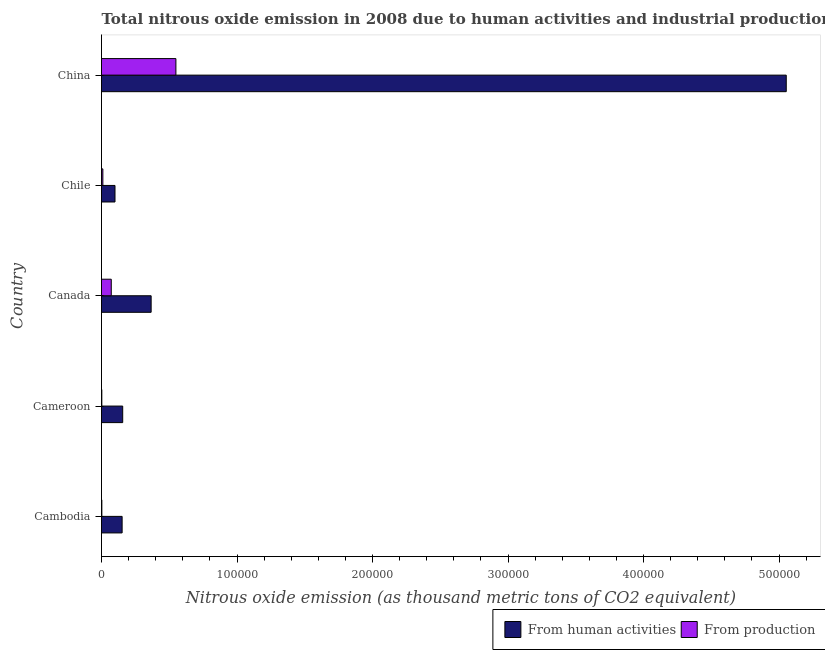How many groups of bars are there?
Make the answer very short. 5. Are the number of bars on each tick of the Y-axis equal?
Keep it short and to the point. Yes. How many bars are there on the 2nd tick from the top?
Make the answer very short. 2. How many bars are there on the 2nd tick from the bottom?
Offer a terse response. 2. What is the label of the 5th group of bars from the top?
Your answer should be very brief. Cambodia. What is the amount of emissions from human activities in China?
Offer a terse response. 5.05e+05. Across all countries, what is the maximum amount of emissions from human activities?
Keep it short and to the point. 5.05e+05. Across all countries, what is the minimum amount of emissions generated from industries?
Keep it short and to the point. 235.8. In which country was the amount of emissions from human activities maximum?
Offer a terse response. China. In which country was the amount of emissions generated from industries minimum?
Provide a short and direct response. Cameroon. What is the total amount of emissions from human activities in the graph?
Provide a short and direct response. 5.83e+05. What is the difference between the amount of emissions from human activities in Cambodia and that in Chile?
Your response must be concise. 5260.5. What is the difference between the amount of emissions from human activities in China and the amount of emissions generated from industries in Canada?
Provide a succinct answer. 4.98e+05. What is the average amount of emissions from human activities per country?
Your answer should be compact. 1.17e+05. What is the difference between the amount of emissions from human activities and amount of emissions generated from industries in Chile?
Make the answer very short. 8954.9. In how many countries, is the amount of emissions from human activities greater than 220000 thousand metric tons?
Provide a succinct answer. 1. What is the ratio of the amount of emissions generated from industries in Cameroon to that in Canada?
Your response must be concise. 0.03. Is the difference between the amount of emissions from human activities in Cambodia and Cameroon greater than the difference between the amount of emissions generated from industries in Cambodia and Cameroon?
Your answer should be compact. No. What is the difference between the highest and the second highest amount of emissions from human activities?
Offer a terse response. 4.69e+05. What is the difference between the highest and the lowest amount of emissions generated from industries?
Provide a short and direct response. 5.47e+04. In how many countries, is the amount of emissions from human activities greater than the average amount of emissions from human activities taken over all countries?
Provide a succinct answer. 1. What does the 1st bar from the top in Canada represents?
Your response must be concise. From production. What does the 1st bar from the bottom in Cameroon represents?
Provide a succinct answer. From human activities. How many countries are there in the graph?
Provide a succinct answer. 5. Does the graph contain grids?
Give a very brief answer. No. Where does the legend appear in the graph?
Provide a short and direct response. Bottom right. How many legend labels are there?
Offer a very short reply. 2. What is the title of the graph?
Your answer should be compact. Total nitrous oxide emission in 2008 due to human activities and industrial production. What is the label or title of the X-axis?
Provide a succinct answer. Nitrous oxide emission (as thousand metric tons of CO2 equivalent). What is the Nitrous oxide emission (as thousand metric tons of CO2 equivalent) in From human activities in Cambodia?
Offer a very short reply. 1.52e+04. What is the Nitrous oxide emission (as thousand metric tons of CO2 equivalent) of From production in Cambodia?
Your answer should be compact. 257.9. What is the Nitrous oxide emission (as thousand metric tons of CO2 equivalent) in From human activities in Cameroon?
Provide a short and direct response. 1.56e+04. What is the Nitrous oxide emission (as thousand metric tons of CO2 equivalent) of From production in Cameroon?
Ensure brevity in your answer.  235.8. What is the Nitrous oxide emission (as thousand metric tons of CO2 equivalent) of From human activities in Canada?
Your response must be concise. 3.66e+04. What is the Nitrous oxide emission (as thousand metric tons of CO2 equivalent) of From production in Canada?
Keep it short and to the point. 7205.4. What is the Nitrous oxide emission (as thousand metric tons of CO2 equivalent) in From human activities in Chile?
Your answer should be compact. 9956.7. What is the Nitrous oxide emission (as thousand metric tons of CO2 equivalent) in From production in Chile?
Make the answer very short. 1001.8. What is the Nitrous oxide emission (as thousand metric tons of CO2 equivalent) of From human activities in China?
Your answer should be very brief. 5.05e+05. What is the Nitrous oxide emission (as thousand metric tons of CO2 equivalent) of From production in China?
Offer a very short reply. 5.49e+04. Across all countries, what is the maximum Nitrous oxide emission (as thousand metric tons of CO2 equivalent) in From human activities?
Your response must be concise. 5.05e+05. Across all countries, what is the maximum Nitrous oxide emission (as thousand metric tons of CO2 equivalent) in From production?
Make the answer very short. 5.49e+04. Across all countries, what is the minimum Nitrous oxide emission (as thousand metric tons of CO2 equivalent) in From human activities?
Ensure brevity in your answer.  9956.7. Across all countries, what is the minimum Nitrous oxide emission (as thousand metric tons of CO2 equivalent) of From production?
Your answer should be very brief. 235.8. What is the total Nitrous oxide emission (as thousand metric tons of CO2 equivalent) in From human activities in the graph?
Make the answer very short. 5.83e+05. What is the total Nitrous oxide emission (as thousand metric tons of CO2 equivalent) in From production in the graph?
Provide a short and direct response. 6.36e+04. What is the difference between the Nitrous oxide emission (as thousand metric tons of CO2 equivalent) of From human activities in Cambodia and that in Cameroon?
Your answer should be compact. -429.5. What is the difference between the Nitrous oxide emission (as thousand metric tons of CO2 equivalent) in From production in Cambodia and that in Cameroon?
Offer a terse response. 22.1. What is the difference between the Nitrous oxide emission (as thousand metric tons of CO2 equivalent) of From human activities in Cambodia and that in Canada?
Make the answer very short. -2.14e+04. What is the difference between the Nitrous oxide emission (as thousand metric tons of CO2 equivalent) in From production in Cambodia and that in Canada?
Provide a short and direct response. -6947.5. What is the difference between the Nitrous oxide emission (as thousand metric tons of CO2 equivalent) of From human activities in Cambodia and that in Chile?
Provide a short and direct response. 5260.5. What is the difference between the Nitrous oxide emission (as thousand metric tons of CO2 equivalent) in From production in Cambodia and that in Chile?
Your answer should be very brief. -743.9. What is the difference between the Nitrous oxide emission (as thousand metric tons of CO2 equivalent) of From human activities in Cambodia and that in China?
Keep it short and to the point. -4.90e+05. What is the difference between the Nitrous oxide emission (as thousand metric tons of CO2 equivalent) in From production in Cambodia and that in China?
Your response must be concise. -5.46e+04. What is the difference between the Nitrous oxide emission (as thousand metric tons of CO2 equivalent) of From human activities in Cameroon and that in Canada?
Give a very brief answer. -2.10e+04. What is the difference between the Nitrous oxide emission (as thousand metric tons of CO2 equivalent) of From production in Cameroon and that in Canada?
Make the answer very short. -6969.6. What is the difference between the Nitrous oxide emission (as thousand metric tons of CO2 equivalent) of From human activities in Cameroon and that in Chile?
Provide a succinct answer. 5690. What is the difference between the Nitrous oxide emission (as thousand metric tons of CO2 equivalent) in From production in Cameroon and that in Chile?
Your answer should be very brief. -766. What is the difference between the Nitrous oxide emission (as thousand metric tons of CO2 equivalent) of From human activities in Cameroon and that in China?
Your response must be concise. -4.90e+05. What is the difference between the Nitrous oxide emission (as thousand metric tons of CO2 equivalent) in From production in Cameroon and that in China?
Give a very brief answer. -5.47e+04. What is the difference between the Nitrous oxide emission (as thousand metric tons of CO2 equivalent) of From human activities in Canada and that in Chile?
Your answer should be very brief. 2.67e+04. What is the difference between the Nitrous oxide emission (as thousand metric tons of CO2 equivalent) in From production in Canada and that in Chile?
Offer a very short reply. 6203.6. What is the difference between the Nitrous oxide emission (as thousand metric tons of CO2 equivalent) of From human activities in Canada and that in China?
Your answer should be compact. -4.69e+05. What is the difference between the Nitrous oxide emission (as thousand metric tons of CO2 equivalent) in From production in Canada and that in China?
Your response must be concise. -4.77e+04. What is the difference between the Nitrous oxide emission (as thousand metric tons of CO2 equivalent) of From human activities in Chile and that in China?
Offer a terse response. -4.95e+05. What is the difference between the Nitrous oxide emission (as thousand metric tons of CO2 equivalent) of From production in Chile and that in China?
Your answer should be compact. -5.39e+04. What is the difference between the Nitrous oxide emission (as thousand metric tons of CO2 equivalent) in From human activities in Cambodia and the Nitrous oxide emission (as thousand metric tons of CO2 equivalent) in From production in Cameroon?
Provide a succinct answer. 1.50e+04. What is the difference between the Nitrous oxide emission (as thousand metric tons of CO2 equivalent) of From human activities in Cambodia and the Nitrous oxide emission (as thousand metric tons of CO2 equivalent) of From production in Canada?
Keep it short and to the point. 8011.8. What is the difference between the Nitrous oxide emission (as thousand metric tons of CO2 equivalent) of From human activities in Cambodia and the Nitrous oxide emission (as thousand metric tons of CO2 equivalent) of From production in Chile?
Provide a short and direct response. 1.42e+04. What is the difference between the Nitrous oxide emission (as thousand metric tons of CO2 equivalent) of From human activities in Cambodia and the Nitrous oxide emission (as thousand metric tons of CO2 equivalent) of From production in China?
Offer a terse response. -3.97e+04. What is the difference between the Nitrous oxide emission (as thousand metric tons of CO2 equivalent) in From human activities in Cameroon and the Nitrous oxide emission (as thousand metric tons of CO2 equivalent) in From production in Canada?
Provide a succinct answer. 8441.3. What is the difference between the Nitrous oxide emission (as thousand metric tons of CO2 equivalent) in From human activities in Cameroon and the Nitrous oxide emission (as thousand metric tons of CO2 equivalent) in From production in Chile?
Offer a terse response. 1.46e+04. What is the difference between the Nitrous oxide emission (as thousand metric tons of CO2 equivalent) of From human activities in Cameroon and the Nitrous oxide emission (as thousand metric tons of CO2 equivalent) of From production in China?
Make the answer very short. -3.93e+04. What is the difference between the Nitrous oxide emission (as thousand metric tons of CO2 equivalent) of From human activities in Canada and the Nitrous oxide emission (as thousand metric tons of CO2 equivalent) of From production in Chile?
Ensure brevity in your answer.  3.56e+04. What is the difference between the Nitrous oxide emission (as thousand metric tons of CO2 equivalent) in From human activities in Canada and the Nitrous oxide emission (as thousand metric tons of CO2 equivalent) in From production in China?
Offer a very short reply. -1.83e+04. What is the difference between the Nitrous oxide emission (as thousand metric tons of CO2 equivalent) of From human activities in Chile and the Nitrous oxide emission (as thousand metric tons of CO2 equivalent) of From production in China?
Offer a very short reply. -4.49e+04. What is the average Nitrous oxide emission (as thousand metric tons of CO2 equivalent) of From human activities per country?
Keep it short and to the point. 1.17e+05. What is the average Nitrous oxide emission (as thousand metric tons of CO2 equivalent) of From production per country?
Offer a terse response. 1.27e+04. What is the difference between the Nitrous oxide emission (as thousand metric tons of CO2 equivalent) of From human activities and Nitrous oxide emission (as thousand metric tons of CO2 equivalent) of From production in Cambodia?
Offer a terse response. 1.50e+04. What is the difference between the Nitrous oxide emission (as thousand metric tons of CO2 equivalent) in From human activities and Nitrous oxide emission (as thousand metric tons of CO2 equivalent) in From production in Cameroon?
Offer a very short reply. 1.54e+04. What is the difference between the Nitrous oxide emission (as thousand metric tons of CO2 equivalent) in From human activities and Nitrous oxide emission (as thousand metric tons of CO2 equivalent) in From production in Canada?
Offer a terse response. 2.94e+04. What is the difference between the Nitrous oxide emission (as thousand metric tons of CO2 equivalent) in From human activities and Nitrous oxide emission (as thousand metric tons of CO2 equivalent) in From production in Chile?
Ensure brevity in your answer.  8954.9. What is the difference between the Nitrous oxide emission (as thousand metric tons of CO2 equivalent) of From human activities and Nitrous oxide emission (as thousand metric tons of CO2 equivalent) of From production in China?
Offer a very short reply. 4.50e+05. What is the ratio of the Nitrous oxide emission (as thousand metric tons of CO2 equivalent) in From human activities in Cambodia to that in Cameroon?
Provide a succinct answer. 0.97. What is the ratio of the Nitrous oxide emission (as thousand metric tons of CO2 equivalent) of From production in Cambodia to that in Cameroon?
Your answer should be compact. 1.09. What is the ratio of the Nitrous oxide emission (as thousand metric tons of CO2 equivalent) in From human activities in Cambodia to that in Canada?
Keep it short and to the point. 0.42. What is the ratio of the Nitrous oxide emission (as thousand metric tons of CO2 equivalent) in From production in Cambodia to that in Canada?
Your response must be concise. 0.04. What is the ratio of the Nitrous oxide emission (as thousand metric tons of CO2 equivalent) of From human activities in Cambodia to that in Chile?
Give a very brief answer. 1.53. What is the ratio of the Nitrous oxide emission (as thousand metric tons of CO2 equivalent) in From production in Cambodia to that in Chile?
Your answer should be very brief. 0.26. What is the ratio of the Nitrous oxide emission (as thousand metric tons of CO2 equivalent) in From human activities in Cambodia to that in China?
Offer a terse response. 0.03. What is the ratio of the Nitrous oxide emission (as thousand metric tons of CO2 equivalent) in From production in Cambodia to that in China?
Give a very brief answer. 0. What is the ratio of the Nitrous oxide emission (as thousand metric tons of CO2 equivalent) of From human activities in Cameroon to that in Canada?
Offer a terse response. 0.43. What is the ratio of the Nitrous oxide emission (as thousand metric tons of CO2 equivalent) of From production in Cameroon to that in Canada?
Provide a succinct answer. 0.03. What is the ratio of the Nitrous oxide emission (as thousand metric tons of CO2 equivalent) in From human activities in Cameroon to that in Chile?
Your answer should be very brief. 1.57. What is the ratio of the Nitrous oxide emission (as thousand metric tons of CO2 equivalent) in From production in Cameroon to that in Chile?
Your answer should be very brief. 0.24. What is the ratio of the Nitrous oxide emission (as thousand metric tons of CO2 equivalent) of From human activities in Cameroon to that in China?
Provide a short and direct response. 0.03. What is the ratio of the Nitrous oxide emission (as thousand metric tons of CO2 equivalent) of From production in Cameroon to that in China?
Your answer should be very brief. 0. What is the ratio of the Nitrous oxide emission (as thousand metric tons of CO2 equivalent) in From human activities in Canada to that in Chile?
Ensure brevity in your answer.  3.68. What is the ratio of the Nitrous oxide emission (as thousand metric tons of CO2 equivalent) of From production in Canada to that in Chile?
Make the answer very short. 7.19. What is the ratio of the Nitrous oxide emission (as thousand metric tons of CO2 equivalent) in From human activities in Canada to that in China?
Ensure brevity in your answer.  0.07. What is the ratio of the Nitrous oxide emission (as thousand metric tons of CO2 equivalent) of From production in Canada to that in China?
Offer a very short reply. 0.13. What is the ratio of the Nitrous oxide emission (as thousand metric tons of CO2 equivalent) in From human activities in Chile to that in China?
Your answer should be compact. 0.02. What is the ratio of the Nitrous oxide emission (as thousand metric tons of CO2 equivalent) in From production in Chile to that in China?
Your answer should be very brief. 0.02. What is the difference between the highest and the second highest Nitrous oxide emission (as thousand metric tons of CO2 equivalent) in From human activities?
Your answer should be very brief. 4.69e+05. What is the difference between the highest and the second highest Nitrous oxide emission (as thousand metric tons of CO2 equivalent) of From production?
Make the answer very short. 4.77e+04. What is the difference between the highest and the lowest Nitrous oxide emission (as thousand metric tons of CO2 equivalent) in From human activities?
Make the answer very short. 4.95e+05. What is the difference between the highest and the lowest Nitrous oxide emission (as thousand metric tons of CO2 equivalent) of From production?
Provide a short and direct response. 5.47e+04. 